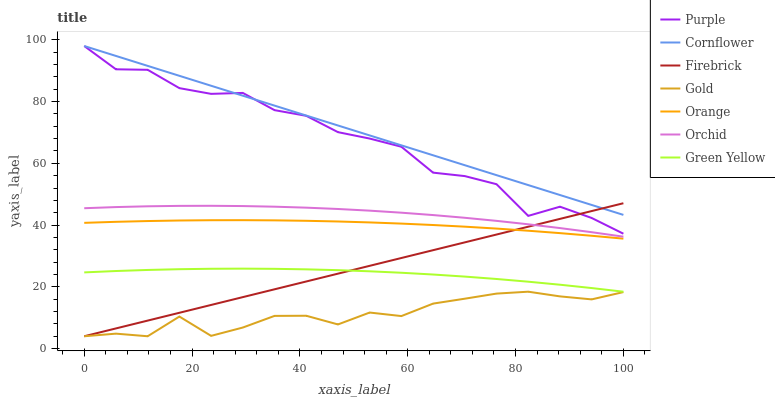Does Purple have the minimum area under the curve?
Answer yes or no. No. Does Purple have the maximum area under the curve?
Answer yes or no. No. Is Gold the smoothest?
Answer yes or no. No. Is Gold the roughest?
Answer yes or no. No. Does Purple have the lowest value?
Answer yes or no. No. Does Gold have the highest value?
Answer yes or no. No. Is Green Yellow less than Purple?
Answer yes or no. Yes. Is Cornflower greater than Orchid?
Answer yes or no. Yes. Does Green Yellow intersect Purple?
Answer yes or no. No. 